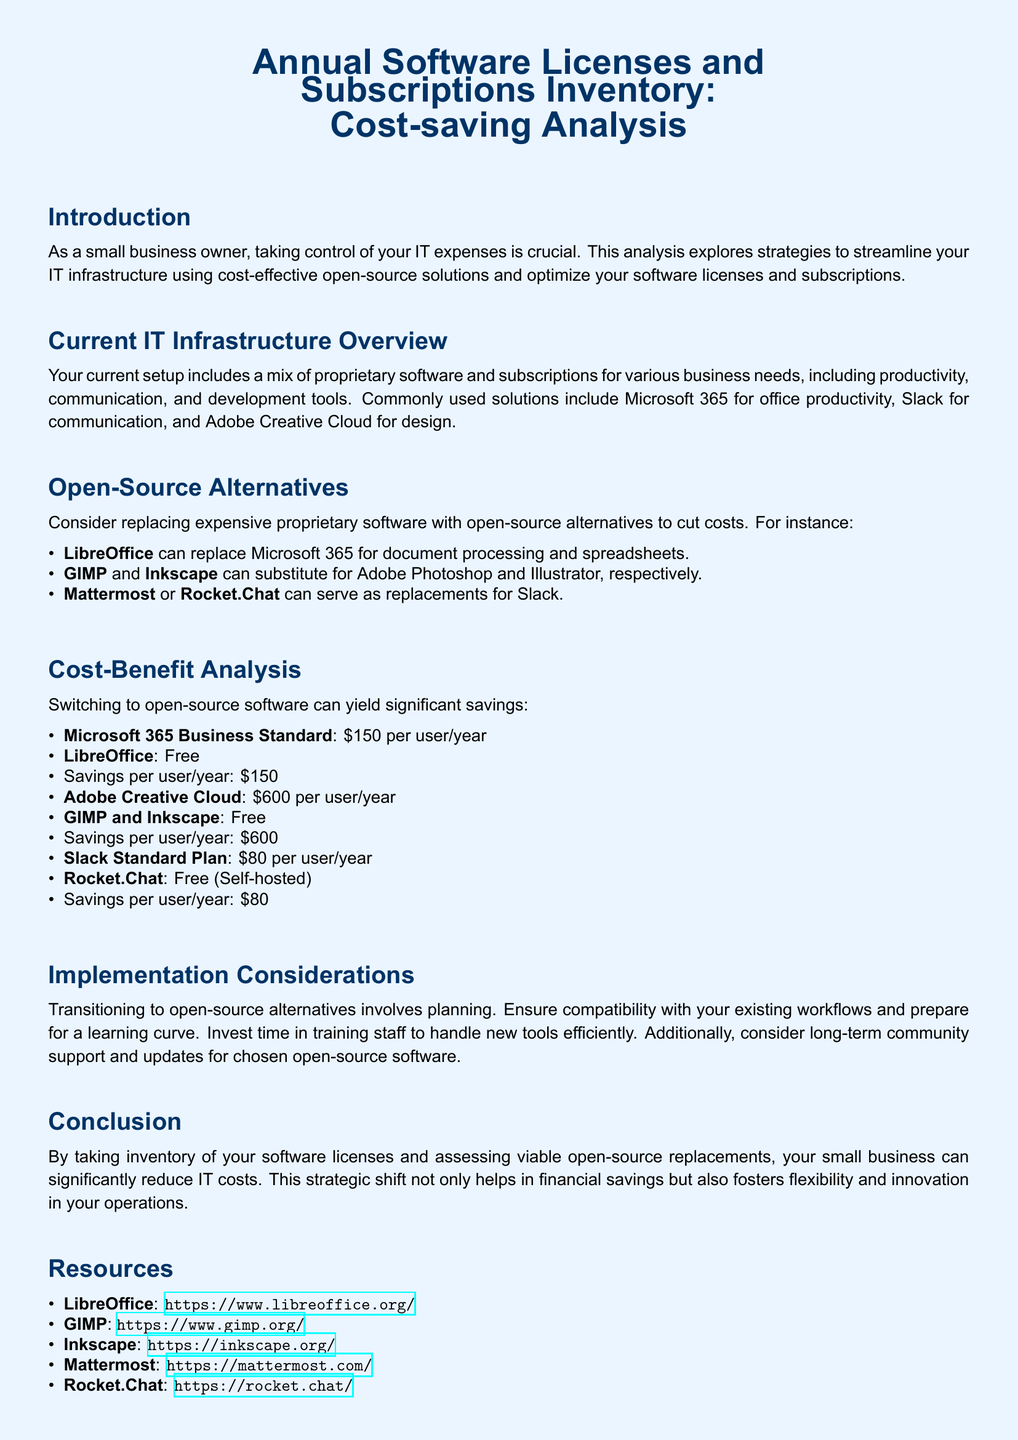What is the main purpose of this analysis? The analysis explores strategies to streamline IT infrastructure using cost-effective open-source solutions and optimize software licenses and subscriptions.
Answer: Cost-saving analysis What is the annual cost of Microsoft 365 Business Standard per user? The cost listed in the document for Microsoft 365 Business Standard is $150 per user per year.
Answer: $150 Which software can replace Adobe Creative Cloud? The document suggests using GIMP and Inkscape as replacements for Adobe Creative Cloud.
Answer: GIMP and Inkscape What is the savings per user per year when switching from Slack Standard Plan to Rocket.Chat? The savings calculation is based on the difference between the Slack Standard Plan ($80) and Rocket.Chat (free).
Answer: $80 What should be considered when transitioning to open-source alternatives? The document mentions ensuring compatibility with existing workflows and preparing for a learning curve as considerations.
Answer: Compatibility and training What open-source software can replace Microsoft 365 for document processing? The suggested replacement for Microsoft 365 in the analysis is LibreOffice.
Answer: LibreOffice What is the annual cost of Adobe Creative Cloud? The document specifies that the annual cost for Adobe Creative Cloud is $600 per user per year.
Answer: $600 What type of support should be considered for chosen open-source software? Long-term community support and updates are emphasized as important considerations for open-source software.
Answer: Community support What color scheme is used in the document? The document features a light blue page color with dark blue text for headings.
Answer: Light blue and dark blue 